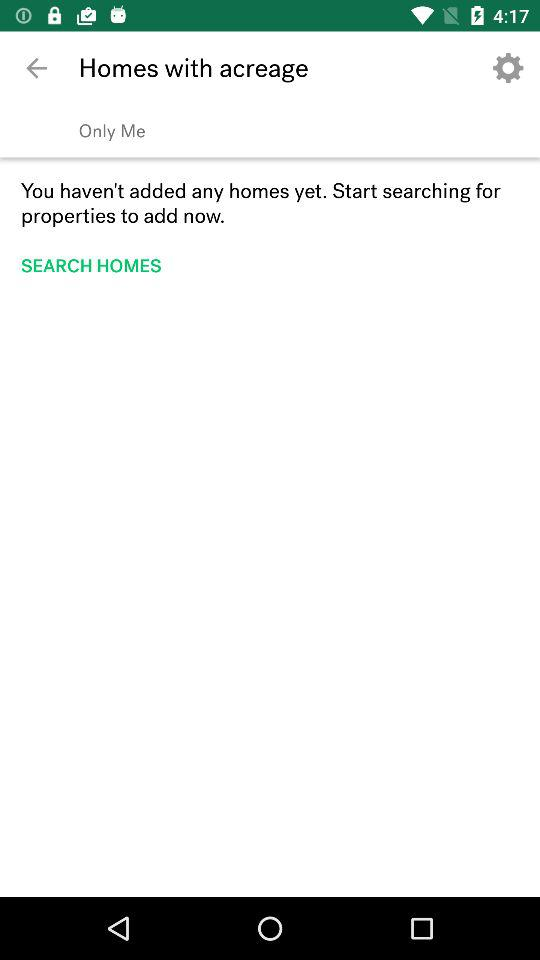How many homes do you currently have?
Answer the question using a single word or phrase. 0 